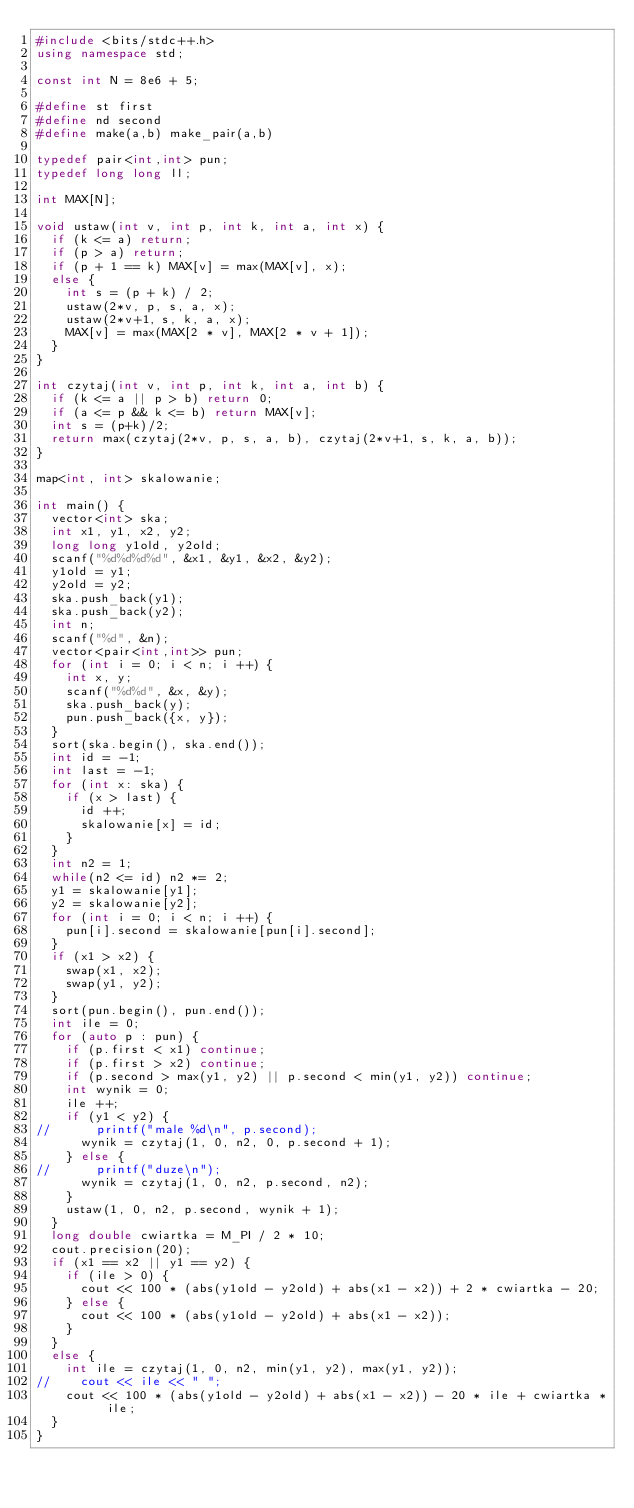<code> <loc_0><loc_0><loc_500><loc_500><_C++_>#include <bits/stdc++.h>
using namespace std;

const int N = 8e6 + 5;

#define st first
#define nd second
#define make(a,b) make_pair(a,b)

typedef pair<int,int> pun;
typedef long long ll;

int MAX[N];

void ustaw(int v, int p, int k, int a, int x) {
	if (k <= a) return;
	if (p > a) return;
	if (p + 1 == k) MAX[v] = max(MAX[v], x);
	else {
		int s = (p + k) / 2;
		ustaw(2*v, p, s, a, x);
		ustaw(2*v+1, s, k, a, x);
		MAX[v] = max(MAX[2 * v], MAX[2 * v + 1]);
	}
}

int czytaj(int v, int p, int k, int a, int b) {
	if (k <= a || p > b) return 0;
	if (a <= p && k <= b) return MAX[v];
	int s = (p+k)/2;
	return max(czytaj(2*v, p, s, a, b), czytaj(2*v+1, s, k, a, b));
}

map<int, int> skalowanie;

int main() {
	vector<int> ska;
	int x1, y1, x2, y2;
	long long y1old, y2old;
	scanf("%d%d%d%d", &x1, &y1, &x2, &y2);
	y1old = y1;
	y2old = y2;
	ska.push_back(y1);
	ska.push_back(y2);
	int n;
	scanf("%d", &n);
	vector<pair<int,int>> pun;
	for (int i = 0; i < n; i ++) {
		int x, y;
		scanf("%d%d", &x, &y);
		ska.push_back(y);
		pun.push_back({x, y});
	}
	sort(ska.begin(), ska.end());
	int id = -1;
	int last = -1;
	for (int x: ska) {
		if (x > last) {
			id ++;
			skalowanie[x] = id;
		}
	}
	int n2 = 1;
	while(n2 <= id) n2 *= 2;
	y1 = skalowanie[y1];
	y2 = skalowanie[y2];
	for (int i = 0; i < n; i ++) {
		pun[i].second = skalowanie[pun[i].second];
	}
	if (x1 > x2) {
		swap(x1, x2);
		swap(y1, y2);
	}
	sort(pun.begin(), pun.end());
	int ile = 0;
	for (auto p : pun) {
		if (p.first < x1) continue;
		if (p.first > x2) continue;
		if (p.second > max(y1, y2) || p.second < min(y1, y2)) continue;
		int wynik = 0;
		ile ++;
		if (y1 < y2) {
// 			printf("male %d\n", p.second);
			wynik = czytaj(1, 0, n2, 0, p.second + 1);
		} else {
// 			printf("duze\n");
			wynik = czytaj(1, 0, n2, p.second, n2);
		}
		ustaw(1, 0, n2, p.second, wynik + 1);
	}
	long double cwiartka = M_PI / 2 * 10;
	cout.precision(20);
	if (x1 == x2 || y1 == y2) {
		if (ile > 0) {
			cout << 100 * (abs(y1old - y2old) + abs(x1 - x2)) + 2 * cwiartka - 20;
		} else {
			cout << 100 * (abs(y1old - y2old) + abs(x1 - x2));
		}
	}
	else {
		int ile = czytaj(1, 0, n2, min(y1, y2), max(y1, y2));
// 		cout << ile << " ";
		cout << 100 * (abs(y1old - y2old) + abs(x1 - x2)) - 20 * ile + cwiartka * ile;
	}
}
</code> 